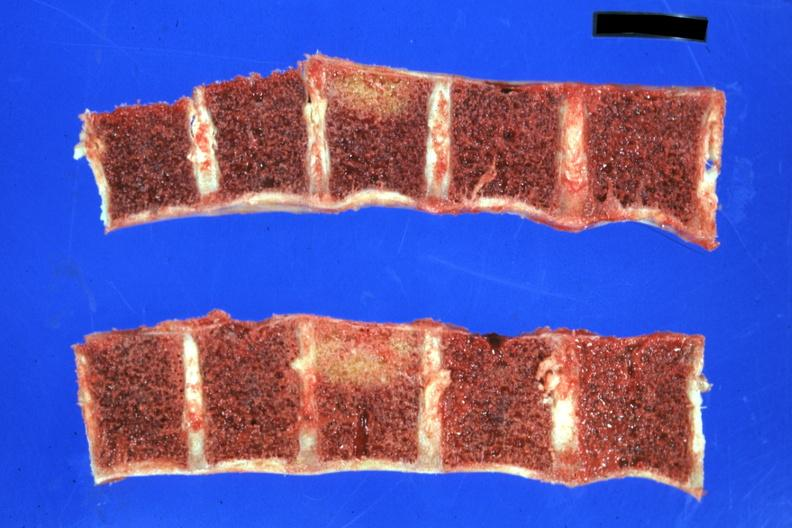what does this image show?
Answer the question using a single word or phrase. Lesions well shown 